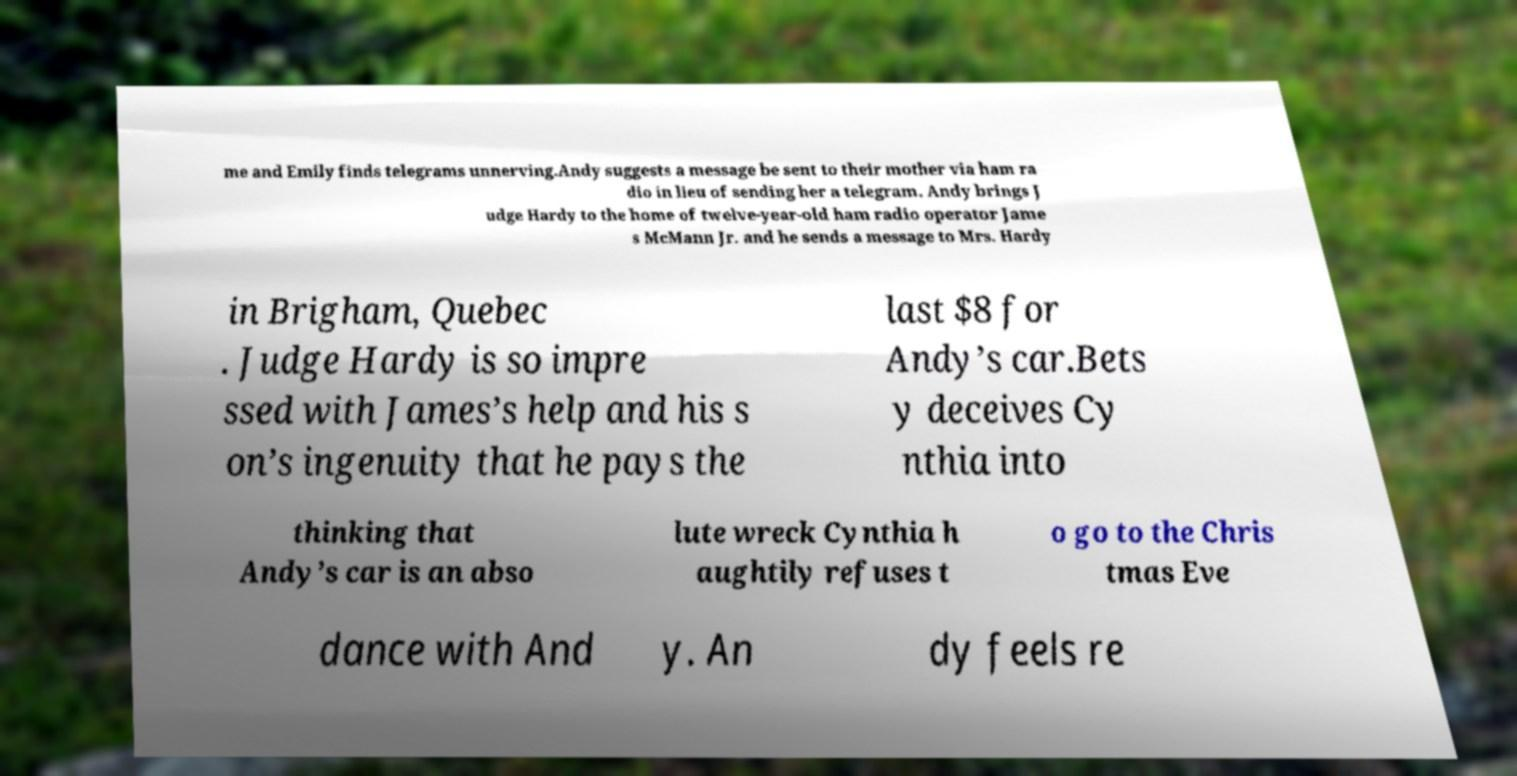Please identify and transcribe the text found in this image. me and Emily finds telegrams unnerving.Andy suggests a message be sent to their mother via ham ra dio in lieu of sending her a telegram. Andy brings J udge Hardy to the home of twelve-year-old ham radio operator Jame s McMann Jr. and he sends a message to Mrs. Hardy in Brigham, Quebec . Judge Hardy is so impre ssed with James’s help and his s on’s ingenuity that he pays the last $8 for Andy’s car.Bets y deceives Cy nthia into thinking that Andy’s car is an abso lute wreck Cynthia h aughtily refuses t o go to the Chris tmas Eve dance with And y. An dy feels re 